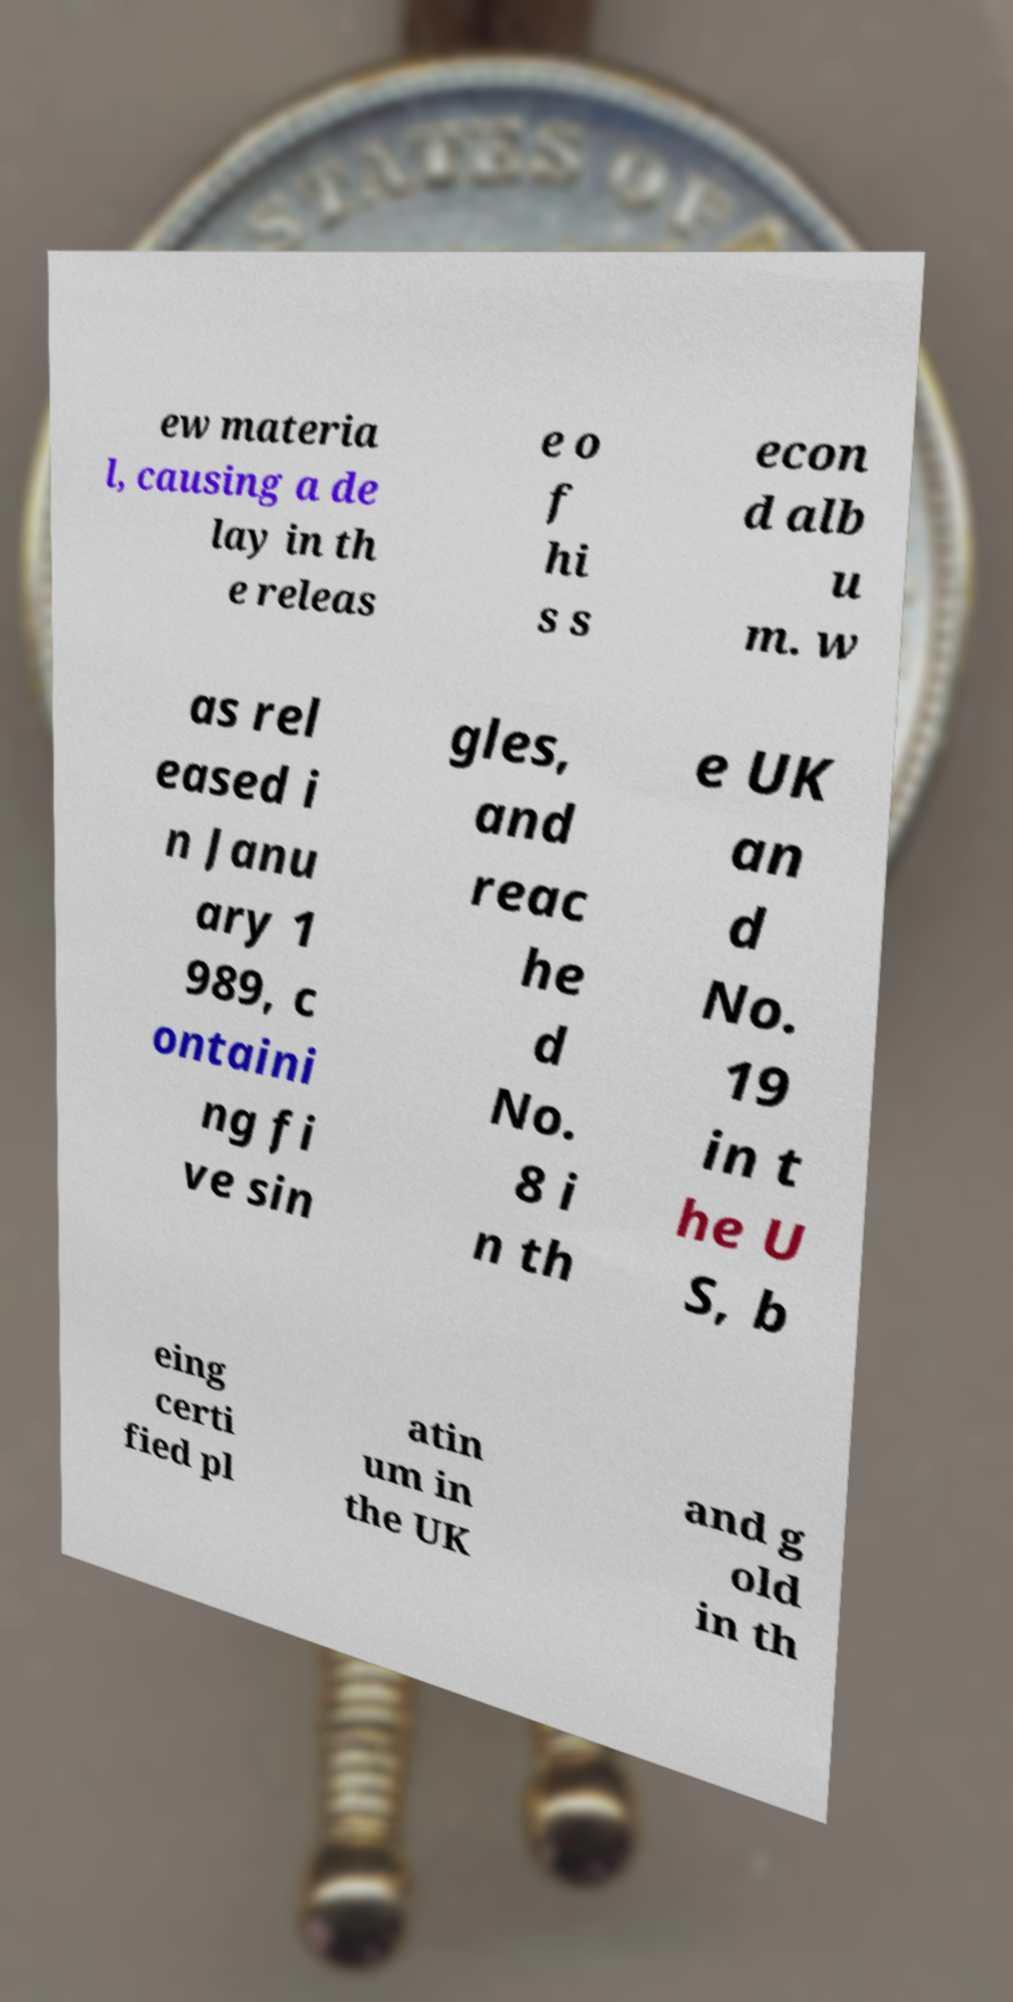There's text embedded in this image that I need extracted. Can you transcribe it verbatim? ew materia l, causing a de lay in th e releas e o f hi s s econ d alb u m. w as rel eased i n Janu ary 1 989, c ontaini ng fi ve sin gles, and reac he d No. 8 i n th e UK an d No. 19 in t he U S, b eing certi fied pl atin um in the UK and g old in th 